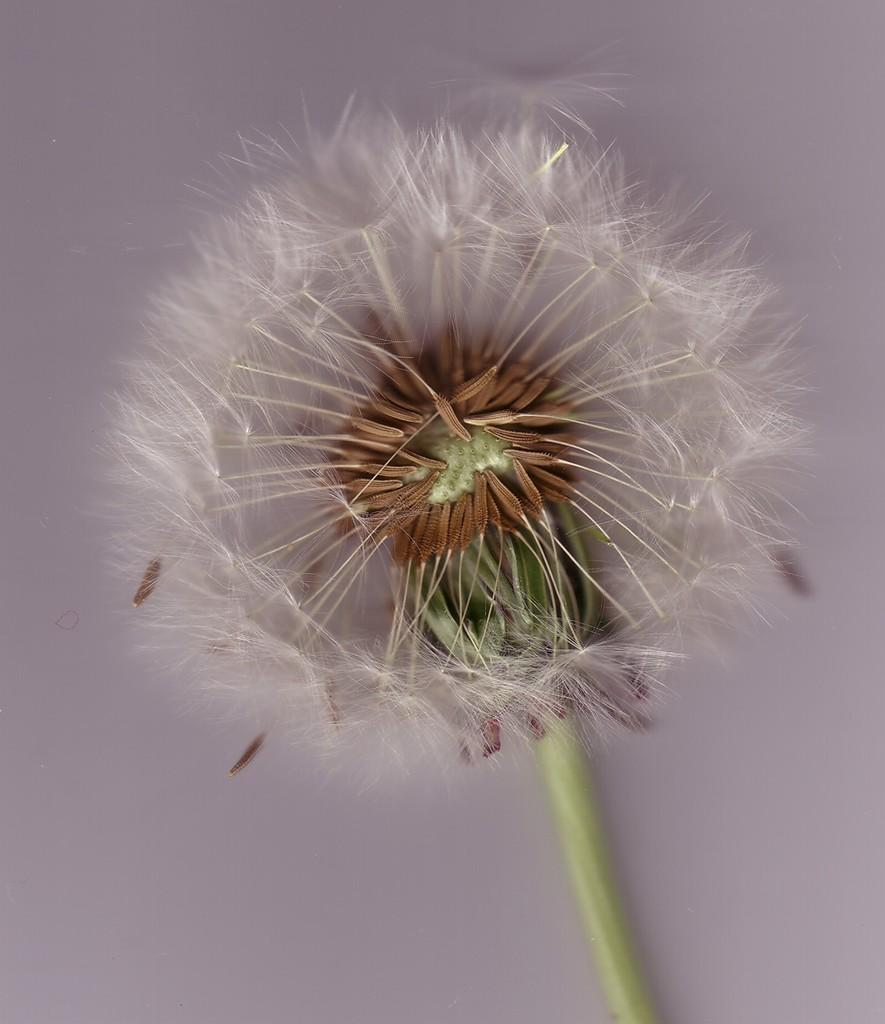What is the main subject of the image? The main subject of the image is a flower. What features does the flower have? The flower has seeds and a stem. What type of holiday can be seen in the background of the image? There is no holiday visible in the image; it only features a flower with seeds and a stem. 